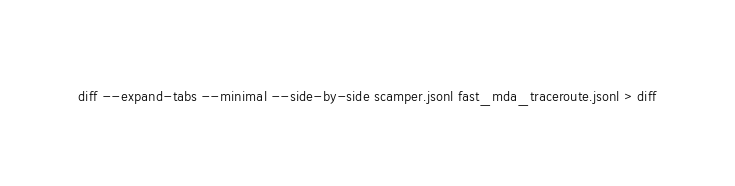Convert code to text. <code><loc_0><loc_0><loc_500><loc_500><_Bash_>diff --expand-tabs --minimal --side-by-side scamper.jsonl fast_mda_traceroute.jsonl > diff
</code> 